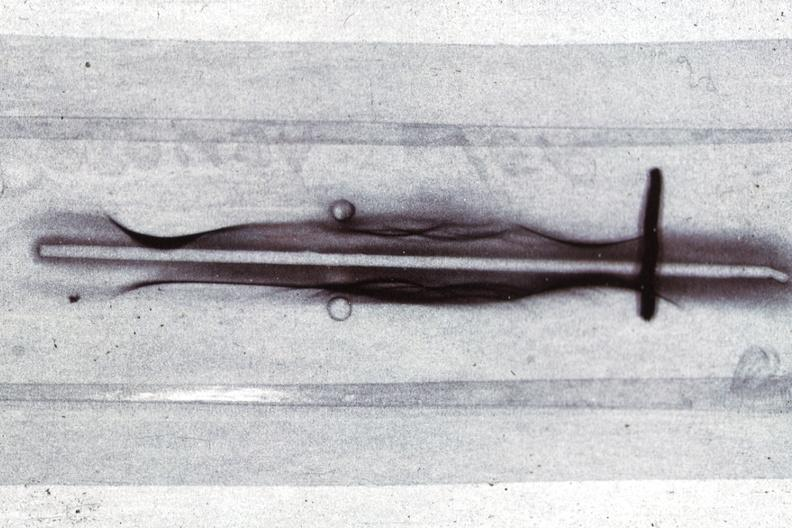s monoclonal gammopathy present?
Answer the question using a single word or phrase. Yes 